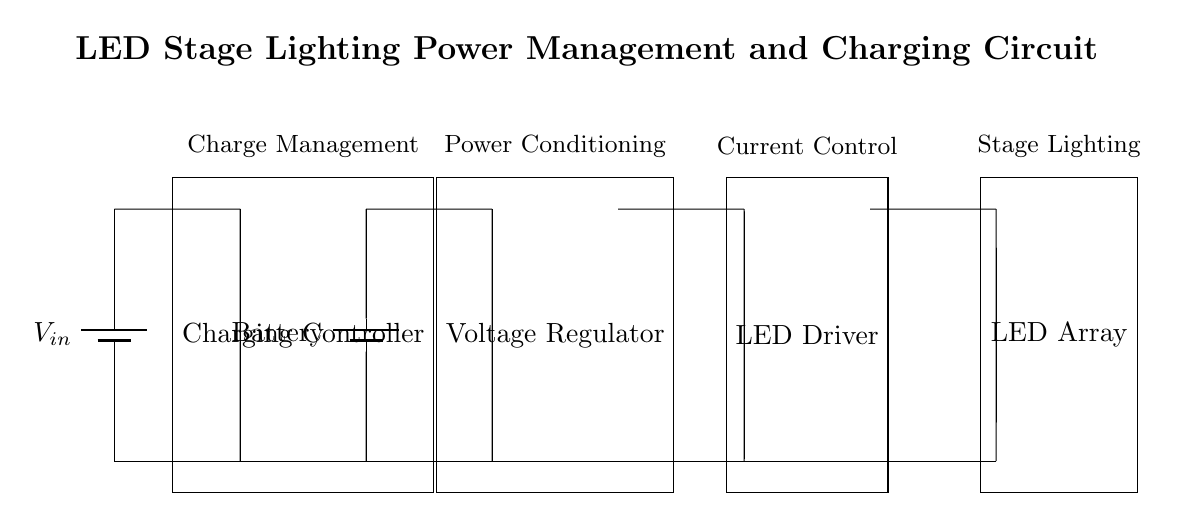What is the input voltage of the circuit? The input voltage is shown as V_in on the battery symbol at the top left of the circuit diagram. This indicates the voltage supplying the circuit.
Answer: V_in What does the charging controller do? The charging controller manages the process of charging the battery from the input voltage source while ensuring safety and efficiency in the charging process.
Answer: Charge management What is the function of the voltage regulator? The voltage regulator ensures that the output voltage maintains a constant level, regardless of variations in input voltage or load conditions, thus protecting downstream components.
Answer: Power conditioning How many main components are in the charging circuit? The main components are the charging controller, battery, voltage regulator, LED driver, and LED array, making a total of five major components in the circuit.
Answer: Five What is the purpose of the LED driver? The LED driver regulates the current flowing to the LED array, ensuring the operation of the LEDs at their required brightness and efficiency by controlling the power supplied.
Answer: Current control How is the ground connected in this circuit? The ground connections are established by connecting the bottom terminals of all the components to a common ground line at the bottom of the circuit, indicated by the short connections.
Answer: Short connections Which component directly powers the LED array? The LED driver powers the LED array directly, as indicated by the connection from the output of the voltage regulator to the input of the LED driver leading to the LED array.
Answer: LED driver 